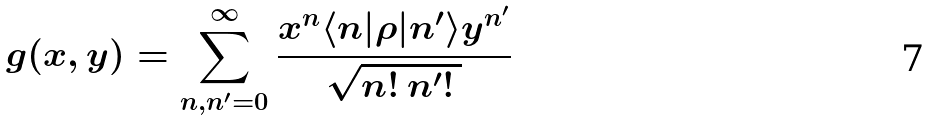Convert formula to latex. <formula><loc_0><loc_0><loc_500><loc_500>g ( x , y ) = \sum _ { n , n ^ { \prime } = 0 } ^ { \infty } \frac { x ^ { n } \langle n | \rho | n ^ { \prime } \rangle y ^ { n ^ { \prime } } } { \sqrt { n ! \, n ^ { \prime } ! \, } }</formula> 